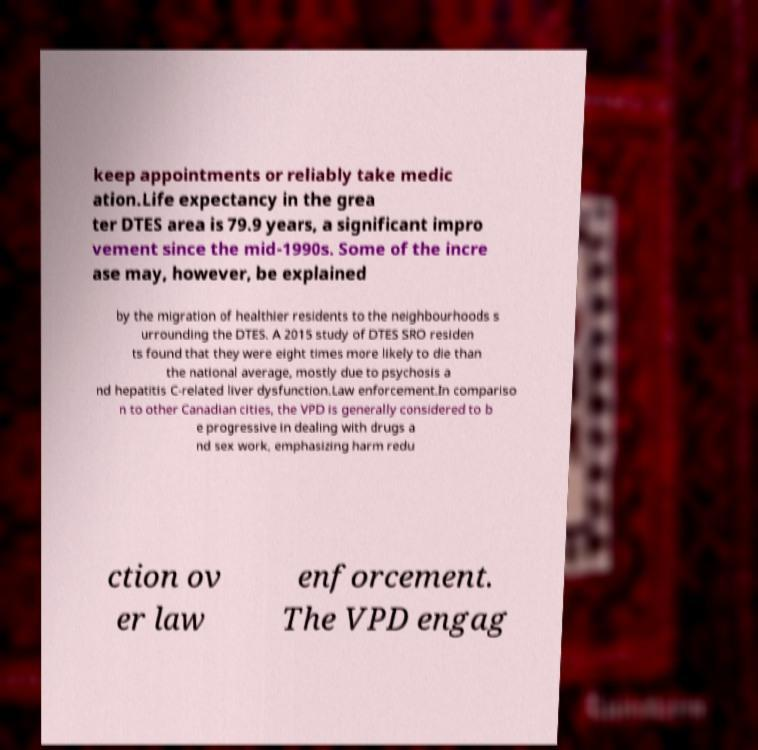Please read and relay the text visible in this image. What does it say? keep appointments or reliably take medic ation.Life expectancy in the grea ter DTES area is 79.9 years, a significant impro vement since the mid-1990s. Some of the incre ase may, however, be explained by the migration of healthier residents to the neighbourhoods s urrounding the DTES. A 2015 study of DTES SRO residen ts found that they were eight times more likely to die than the national average, mostly due to psychosis a nd hepatitis C-related liver dysfunction.Law enforcement.In compariso n to other Canadian cities, the VPD is generally considered to b e progressive in dealing with drugs a nd sex work, emphasizing harm redu ction ov er law enforcement. The VPD engag 